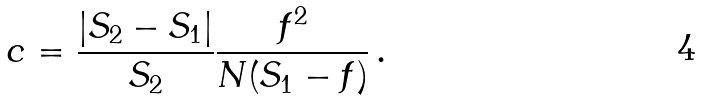<formula> <loc_0><loc_0><loc_500><loc_500>c = { \frac { | S _ { 2 } - S _ { 1 } | } { S _ { 2 } } } { \frac { f ^ { 2 } } { N ( S _ { 1 } - f ) } } \, .</formula> 